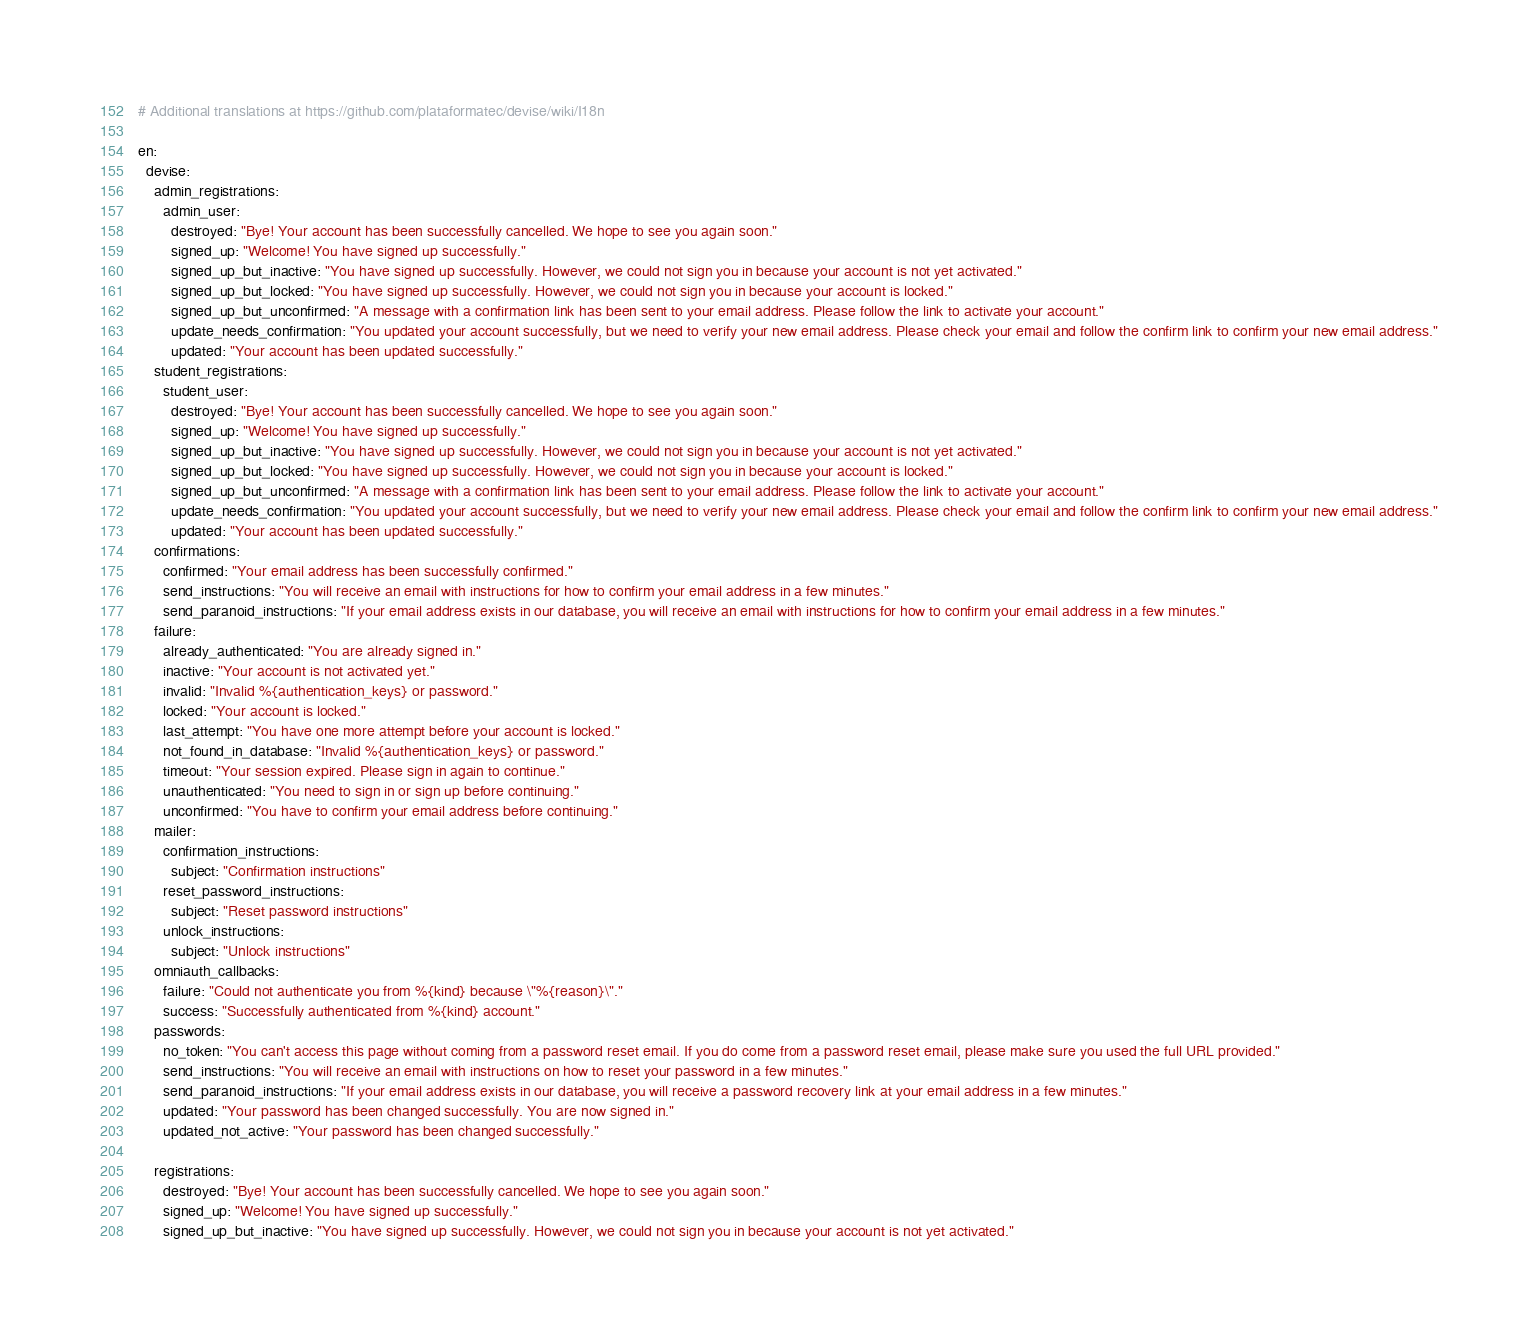Convert code to text. <code><loc_0><loc_0><loc_500><loc_500><_YAML_># Additional translations at https://github.com/plataformatec/devise/wiki/I18n

en:
  devise:
    admin_registrations:
      admin_user:
        destroyed: "Bye! Your account has been successfully cancelled. We hope to see you again soon."
        signed_up: "Welcome! You have signed up successfully."
        signed_up_but_inactive: "You have signed up successfully. However, we could not sign you in because your account is not yet activated."
        signed_up_but_locked: "You have signed up successfully. However, we could not sign you in because your account is locked."
        signed_up_but_unconfirmed: "A message with a confirmation link has been sent to your email address. Please follow the link to activate your account."
        update_needs_confirmation: "You updated your account successfully, but we need to verify your new email address. Please check your email and follow the confirm link to confirm your new email address."
        updated: "Your account has been updated successfully."
    student_registrations:
      student_user:
        destroyed: "Bye! Your account has been successfully cancelled. We hope to see you again soon."
        signed_up: "Welcome! You have signed up successfully."
        signed_up_but_inactive: "You have signed up successfully. However, we could not sign you in because your account is not yet activated."
        signed_up_but_locked: "You have signed up successfully. However, we could not sign you in because your account is locked."
        signed_up_but_unconfirmed: "A message with a confirmation link has been sent to your email address. Please follow the link to activate your account."
        update_needs_confirmation: "You updated your account successfully, but we need to verify your new email address. Please check your email and follow the confirm link to confirm your new email address."
        updated: "Your account has been updated successfully."
    confirmations:
      confirmed: "Your email address has been successfully confirmed."
      send_instructions: "You will receive an email with instructions for how to confirm your email address in a few minutes."
      send_paranoid_instructions: "If your email address exists in our database, you will receive an email with instructions for how to confirm your email address in a few minutes."
    failure:
      already_authenticated: "You are already signed in."
      inactive: "Your account is not activated yet."
      invalid: "Invalid %{authentication_keys} or password."
      locked: "Your account is locked."
      last_attempt: "You have one more attempt before your account is locked."
      not_found_in_database: "Invalid %{authentication_keys} or password."
      timeout: "Your session expired. Please sign in again to continue."
      unauthenticated: "You need to sign in or sign up before continuing."
      unconfirmed: "You have to confirm your email address before continuing."
    mailer:
      confirmation_instructions:
        subject: "Confirmation instructions"
      reset_password_instructions:
        subject: "Reset password instructions"
      unlock_instructions:
        subject: "Unlock instructions"
    omniauth_callbacks:
      failure: "Could not authenticate you from %{kind} because \"%{reason}\"."
      success: "Successfully authenticated from %{kind} account."
    passwords:
      no_token: "You can't access this page without coming from a password reset email. If you do come from a password reset email, please make sure you used the full URL provided."
      send_instructions: "You will receive an email with instructions on how to reset your password in a few minutes."
      send_paranoid_instructions: "If your email address exists in our database, you will receive a password recovery link at your email address in a few minutes."
      updated: "Your password has been changed successfully. You are now signed in."
      updated_not_active: "Your password has been changed successfully."

    registrations:
      destroyed: "Bye! Your account has been successfully cancelled. We hope to see you again soon."
      signed_up: "Welcome! You have signed up successfully."
      signed_up_but_inactive: "You have signed up successfully. However, we could not sign you in because your account is not yet activated."</code> 